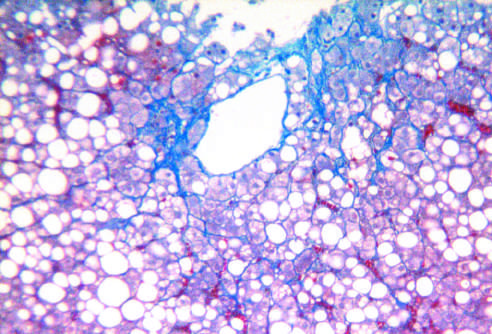s gross examination of a resected sigmoid colon present in a characteristic perisinusoidal chicken wire fence pattern (masson trichrome stain)?
Answer the question using a single word or phrase. No 